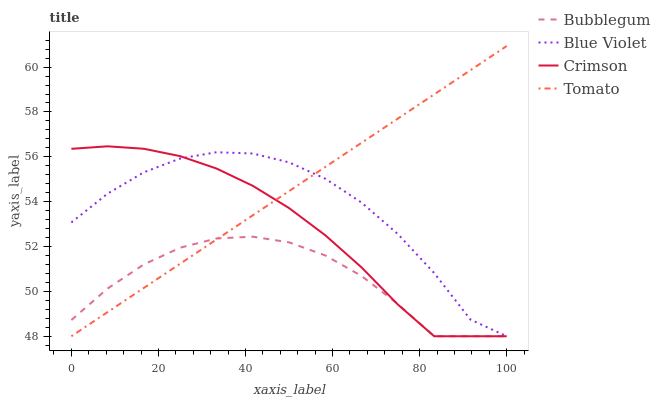Does Bubblegum have the minimum area under the curve?
Answer yes or no. Yes. Does Tomato have the maximum area under the curve?
Answer yes or no. Yes. Does Blue Violet have the minimum area under the curve?
Answer yes or no. No. Does Blue Violet have the maximum area under the curve?
Answer yes or no. No. Is Tomato the smoothest?
Answer yes or no. Yes. Is Blue Violet the roughest?
Answer yes or no. Yes. Is Blue Violet the smoothest?
Answer yes or no. No. Is Tomato the roughest?
Answer yes or no. No. Does Crimson have the lowest value?
Answer yes or no. Yes. Does Tomato have the highest value?
Answer yes or no. Yes. Does Blue Violet have the highest value?
Answer yes or no. No. Does Tomato intersect Crimson?
Answer yes or no. Yes. Is Tomato less than Crimson?
Answer yes or no. No. Is Tomato greater than Crimson?
Answer yes or no. No. 